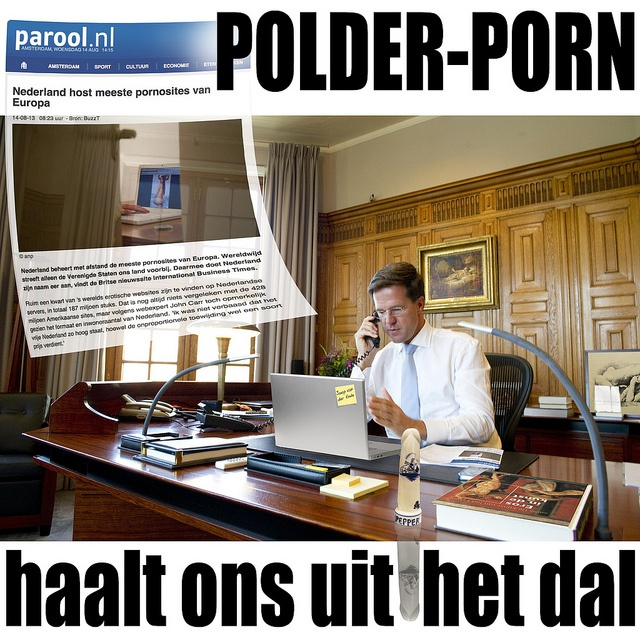Describe the objects in this image and their specific colors. I can see people in white, lightgray, gray, black, and darkgray tones, book in white, black, and brown tones, laptop in white, darkgray, lightgray, gray, and khaki tones, chair in white, black, gray, and maroon tones, and chair in white, black, and gray tones in this image. 